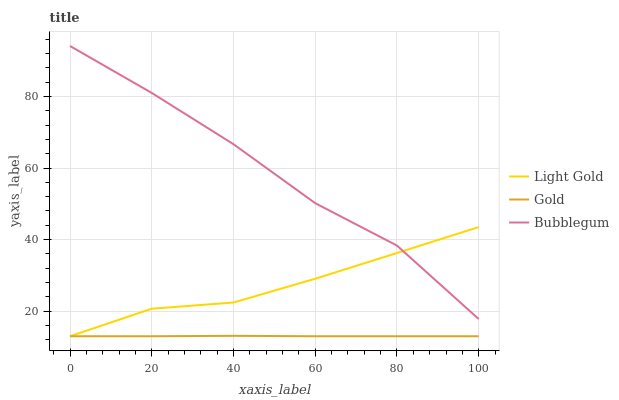Does Gold have the minimum area under the curve?
Answer yes or no. Yes. Does Bubblegum have the maximum area under the curve?
Answer yes or no. Yes. Does Bubblegum have the minimum area under the curve?
Answer yes or no. No. Does Gold have the maximum area under the curve?
Answer yes or no. No. Is Gold the smoothest?
Answer yes or no. Yes. Is Bubblegum the roughest?
Answer yes or no. Yes. Is Bubblegum the smoothest?
Answer yes or no. No. Is Gold the roughest?
Answer yes or no. No. Does Light Gold have the lowest value?
Answer yes or no. Yes. Does Bubblegum have the lowest value?
Answer yes or no. No. Does Bubblegum have the highest value?
Answer yes or no. Yes. Does Gold have the highest value?
Answer yes or no. No. Is Gold less than Bubblegum?
Answer yes or no. Yes. Is Bubblegum greater than Gold?
Answer yes or no. Yes. Does Gold intersect Light Gold?
Answer yes or no. Yes. Is Gold less than Light Gold?
Answer yes or no. No. Is Gold greater than Light Gold?
Answer yes or no. No. Does Gold intersect Bubblegum?
Answer yes or no. No. 